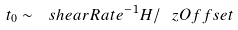Convert formula to latex. <formula><loc_0><loc_0><loc_500><loc_500>t _ { 0 } \sim \ s h e a r R a t e ^ { - 1 } H / \ z O f f s e t</formula> 